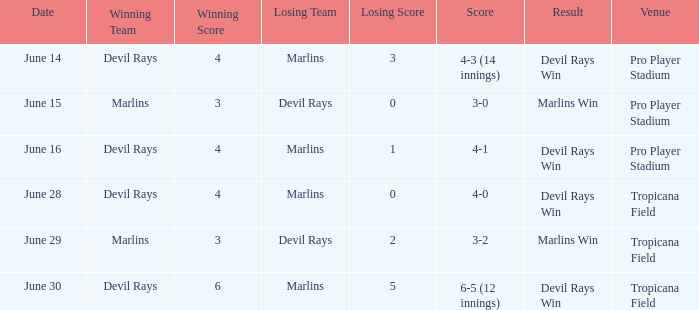Could you help me parse every detail presented in this table? {'header': ['Date', 'Winning Team', 'Winning Score', 'Losing Team', 'Losing Score', 'Score', 'Result', 'Venue'], 'rows': [['June 14', 'Devil Rays', '4', 'Marlins', '3', '4-3 (14 innings)', 'Devil Rays Win', 'Pro Player Stadium'], ['June 15', 'Marlins', '3', 'Devil Rays', '0', '3-0', 'Marlins Win', 'Pro Player Stadium'], ['June 16', 'Devil Rays', '4', 'Marlins', '1', '4-1', 'Devil Rays Win', 'Pro Player Stadium'], ['June 28', 'Devil Rays', '4', 'Marlins', '0', '4-0', 'Devil Rays Win', 'Tropicana Field'], ['June 29', 'Marlins', '3', 'Devil Rays', '2', '3-2', 'Marlins Win', 'Tropicana Field'], ['June 30', 'Devil Rays', '6', 'Marlins', '5', '6-5 (12 innings)', 'Devil Rays Win', 'Tropicana Field']]} What was the score on june 29? 3-2. 